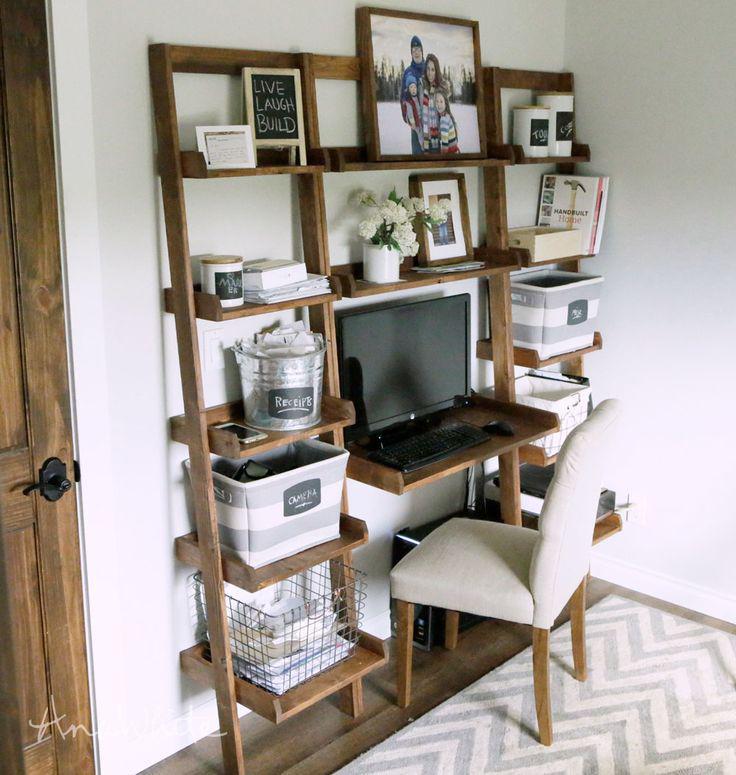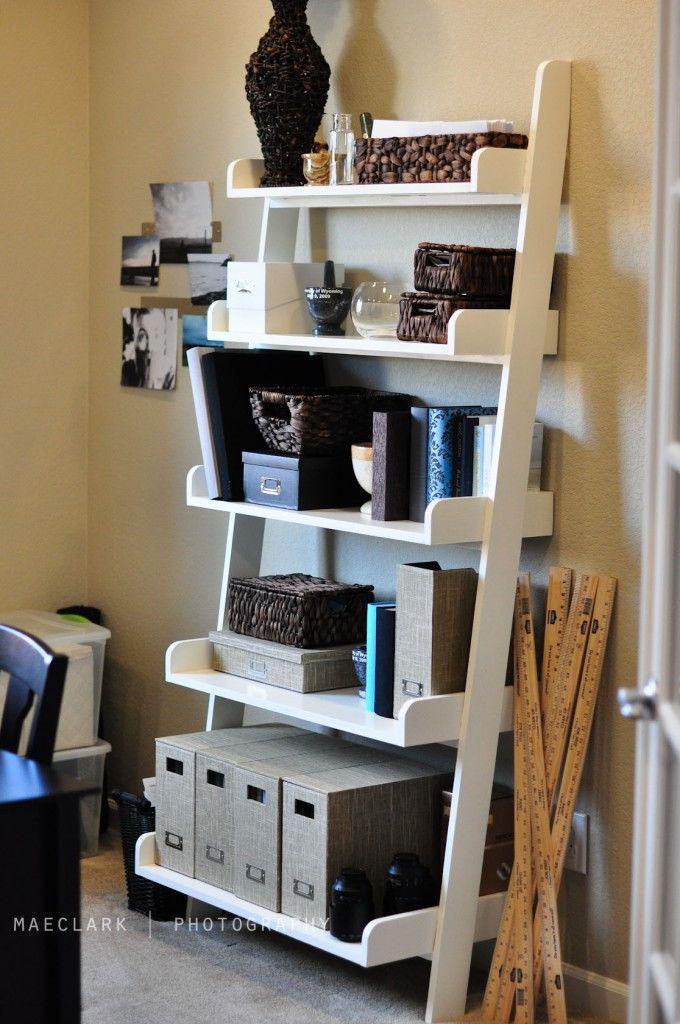The first image is the image on the left, the second image is the image on the right. For the images displayed, is the sentence "The left and right image contains the same number of attached bookshelves." factually correct? Answer yes or no. No. The first image is the image on the left, the second image is the image on the right. Analyze the images presented: Is the assertion "The left image shows a non-white shelf unit that leans against a wall like a ladder and has three vertical sections, with a small desk in the center with a chair pulled up to it." valid? Answer yes or no. Yes. 